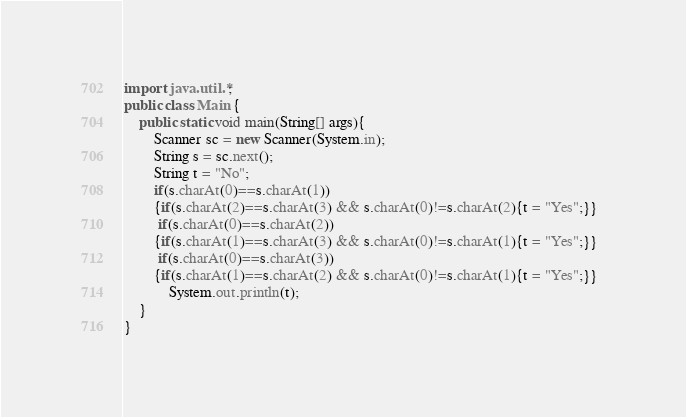Convert code to text. <code><loc_0><loc_0><loc_500><loc_500><_Java_>import java.util.*;
public class Main {
	public static void main(String[] args){
		Scanner sc = new Scanner(System.in);		
		String s = sc.next();
        String t = "No";
        if(s.charAt(0)==s.charAt(1))
        {if(s.charAt(2)==s.charAt(3) && s.charAt(0)!=s.charAt(2){t = "Yes";}}
		 if(s.charAt(0)==s.charAt(2))
        {if(s.charAt(1)==s.charAt(3) && s.charAt(0)!=s.charAt(1){t = "Yes";}}
         if(s.charAt(0)==s.charAt(3))
        {if(s.charAt(1)==s.charAt(2) && s.charAt(0)!=s.charAt(1){t = "Yes";}}  
            System.out.println(t);
	}
}
</code> 